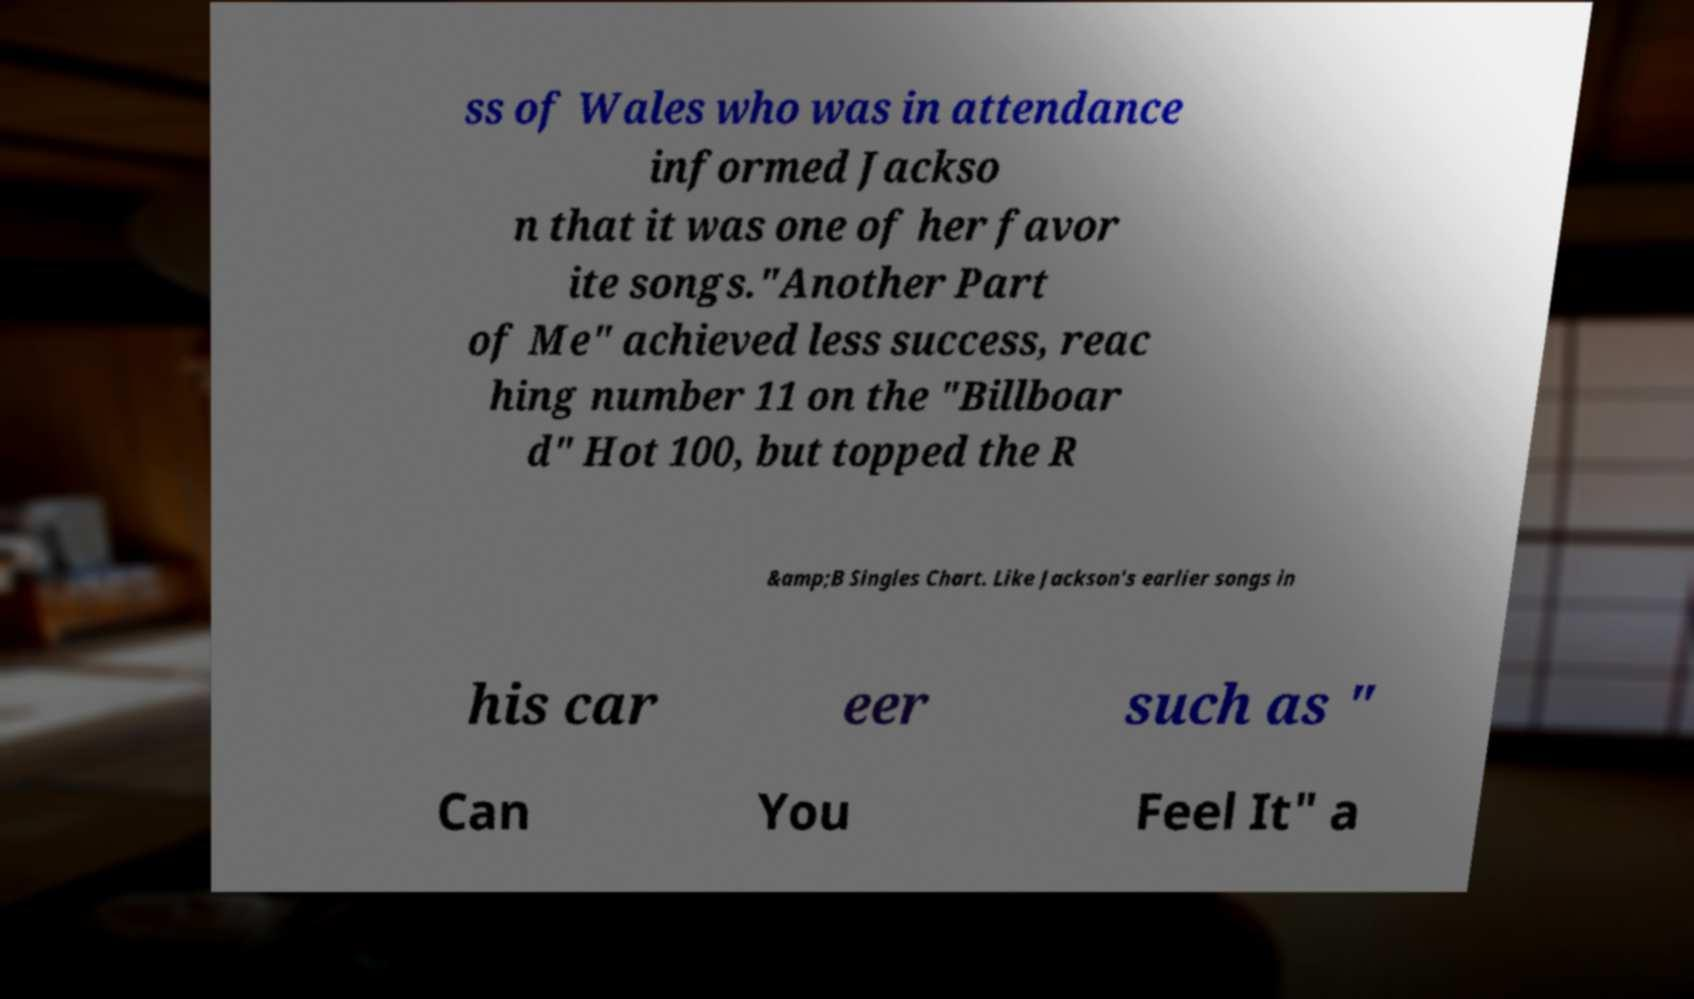Please identify and transcribe the text found in this image. ss of Wales who was in attendance informed Jackso n that it was one of her favor ite songs."Another Part of Me" achieved less success, reac hing number 11 on the "Billboar d" Hot 100, but topped the R &amp;B Singles Chart. Like Jackson's earlier songs in his car eer such as " Can You Feel It" a 